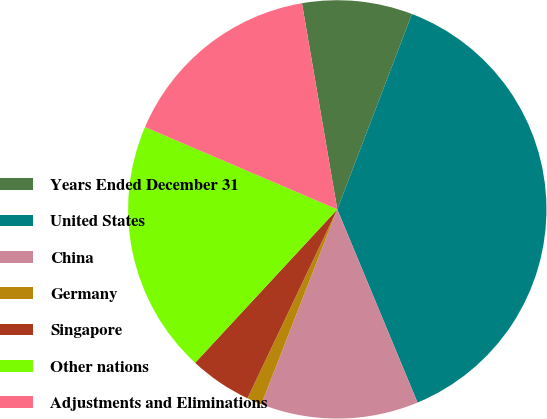Convert chart. <chart><loc_0><loc_0><loc_500><loc_500><pie_chart><fcel>Years Ended December 31<fcel>United States<fcel>China<fcel>Germany<fcel>Singapore<fcel>Other nations<fcel>Adjustments and Eliminations<nl><fcel>8.51%<fcel>37.92%<fcel>12.18%<fcel>1.15%<fcel>4.83%<fcel>19.54%<fcel>15.86%<nl></chart> 